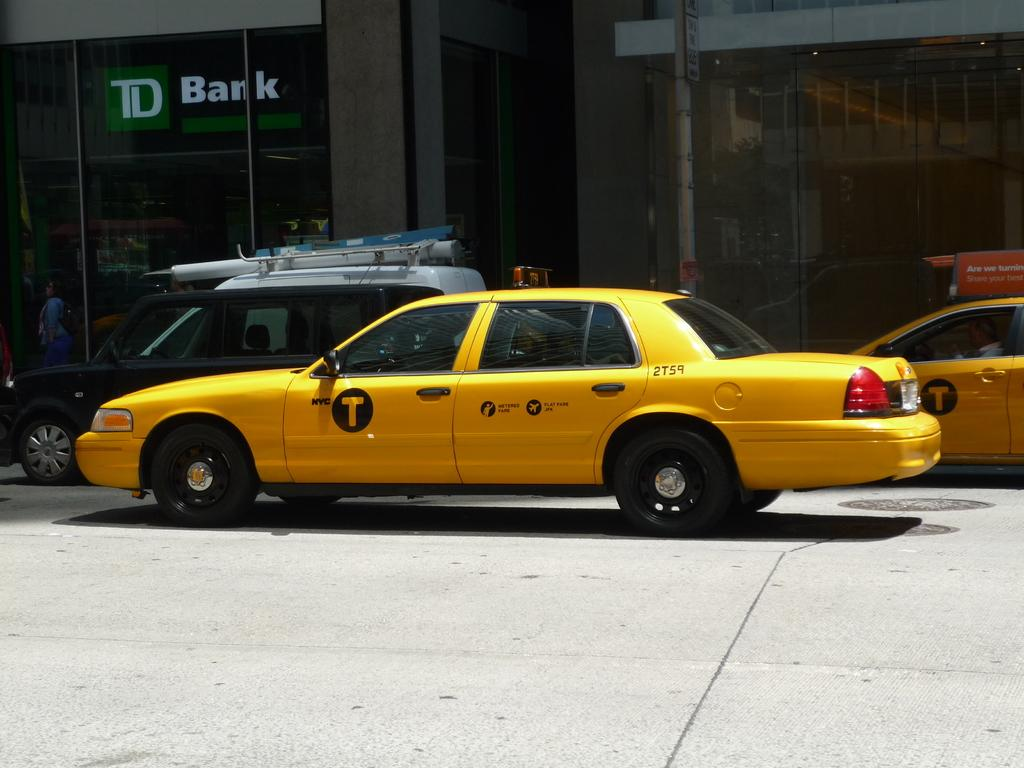Provide a one-sentence caption for the provided image. A yellow taxi says 2T59 on the back. 